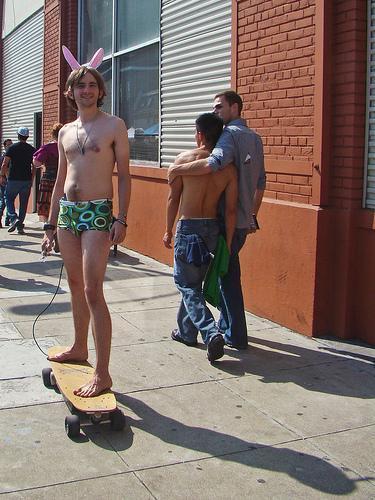How many men are wearing bunny ears?
Give a very brief answer. 1. How many people without shirts are in the image?
Give a very brief answer. 2. 